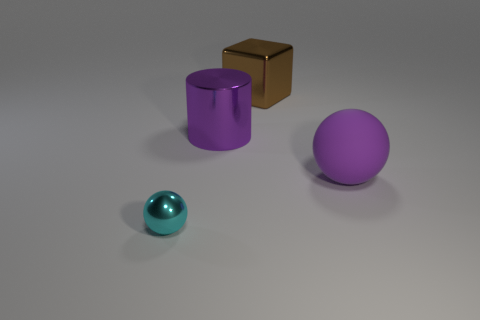Add 3 big blue cylinders. How many objects exist? 7 Subtract 1 balls. How many balls are left? 1 Subtract all cubes. How many objects are left? 3 Add 2 big cubes. How many big cubes are left? 3 Add 3 brown shiny cylinders. How many brown shiny cylinders exist? 3 Subtract 0 cyan cylinders. How many objects are left? 4 Subtract all purple cubes. Subtract all blue cylinders. How many cubes are left? 1 Subtract all small purple spheres. Subtract all cyan things. How many objects are left? 3 